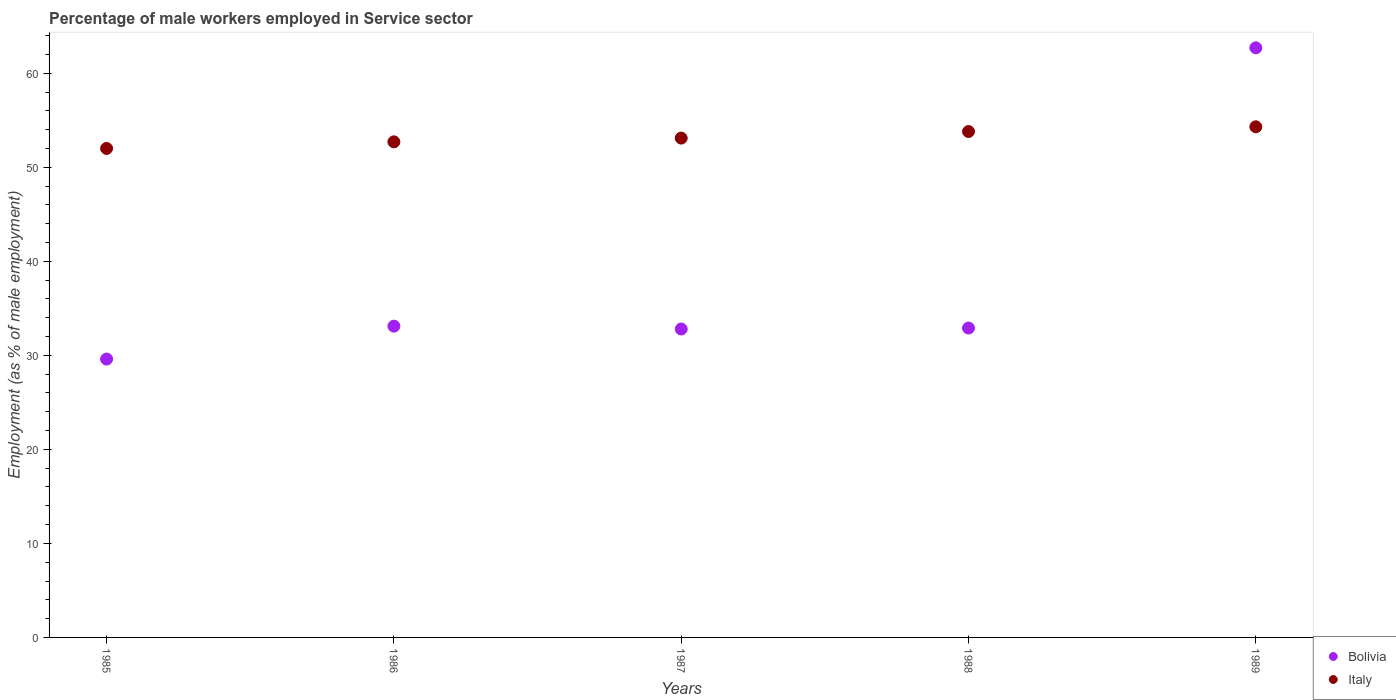How many different coloured dotlines are there?
Provide a succinct answer. 2. What is the percentage of male workers employed in Service sector in Bolivia in 1985?
Ensure brevity in your answer.  29.6. Across all years, what is the maximum percentage of male workers employed in Service sector in Bolivia?
Make the answer very short. 62.7. Across all years, what is the minimum percentage of male workers employed in Service sector in Bolivia?
Keep it short and to the point. 29.6. In which year was the percentage of male workers employed in Service sector in Bolivia maximum?
Keep it short and to the point. 1989. In which year was the percentage of male workers employed in Service sector in Italy minimum?
Give a very brief answer. 1985. What is the total percentage of male workers employed in Service sector in Italy in the graph?
Your response must be concise. 265.9. What is the difference between the percentage of male workers employed in Service sector in Bolivia in 1985 and that in 1988?
Give a very brief answer. -3.3. What is the average percentage of male workers employed in Service sector in Italy per year?
Offer a very short reply. 53.18. In the year 1986, what is the difference between the percentage of male workers employed in Service sector in Bolivia and percentage of male workers employed in Service sector in Italy?
Provide a succinct answer. -19.6. What is the ratio of the percentage of male workers employed in Service sector in Italy in 1987 to that in 1988?
Make the answer very short. 0.99. Is the difference between the percentage of male workers employed in Service sector in Bolivia in 1986 and 1987 greater than the difference between the percentage of male workers employed in Service sector in Italy in 1986 and 1987?
Your answer should be very brief. Yes. What is the difference between the highest and the second highest percentage of male workers employed in Service sector in Italy?
Give a very brief answer. 0.5. What is the difference between the highest and the lowest percentage of male workers employed in Service sector in Italy?
Your answer should be compact. 2.3. Does the percentage of male workers employed in Service sector in Italy monotonically increase over the years?
Keep it short and to the point. Yes. Is the percentage of male workers employed in Service sector in Bolivia strictly greater than the percentage of male workers employed in Service sector in Italy over the years?
Offer a very short reply. No. How many years are there in the graph?
Give a very brief answer. 5. What is the difference between two consecutive major ticks on the Y-axis?
Your answer should be very brief. 10. Does the graph contain any zero values?
Offer a very short reply. No. Does the graph contain grids?
Offer a terse response. No. How many legend labels are there?
Keep it short and to the point. 2. What is the title of the graph?
Provide a succinct answer. Percentage of male workers employed in Service sector. Does "Thailand" appear as one of the legend labels in the graph?
Give a very brief answer. No. What is the label or title of the Y-axis?
Ensure brevity in your answer.  Employment (as % of male employment). What is the Employment (as % of male employment) of Bolivia in 1985?
Give a very brief answer. 29.6. What is the Employment (as % of male employment) of Italy in 1985?
Provide a succinct answer. 52. What is the Employment (as % of male employment) in Bolivia in 1986?
Keep it short and to the point. 33.1. What is the Employment (as % of male employment) of Italy in 1986?
Your response must be concise. 52.7. What is the Employment (as % of male employment) in Bolivia in 1987?
Provide a short and direct response. 32.8. What is the Employment (as % of male employment) of Italy in 1987?
Provide a short and direct response. 53.1. What is the Employment (as % of male employment) in Bolivia in 1988?
Your answer should be compact. 32.9. What is the Employment (as % of male employment) of Italy in 1988?
Your answer should be compact. 53.8. What is the Employment (as % of male employment) in Bolivia in 1989?
Your answer should be compact. 62.7. What is the Employment (as % of male employment) in Italy in 1989?
Your answer should be very brief. 54.3. Across all years, what is the maximum Employment (as % of male employment) in Bolivia?
Your answer should be compact. 62.7. Across all years, what is the maximum Employment (as % of male employment) of Italy?
Your response must be concise. 54.3. Across all years, what is the minimum Employment (as % of male employment) in Bolivia?
Your response must be concise. 29.6. Across all years, what is the minimum Employment (as % of male employment) of Italy?
Your answer should be compact. 52. What is the total Employment (as % of male employment) of Bolivia in the graph?
Provide a short and direct response. 191.1. What is the total Employment (as % of male employment) in Italy in the graph?
Provide a succinct answer. 265.9. What is the difference between the Employment (as % of male employment) of Italy in 1985 and that in 1987?
Keep it short and to the point. -1.1. What is the difference between the Employment (as % of male employment) in Bolivia in 1985 and that in 1988?
Your answer should be compact. -3.3. What is the difference between the Employment (as % of male employment) in Italy in 1985 and that in 1988?
Ensure brevity in your answer.  -1.8. What is the difference between the Employment (as % of male employment) of Bolivia in 1985 and that in 1989?
Provide a short and direct response. -33.1. What is the difference between the Employment (as % of male employment) of Italy in 1986 and that in 1987?
Your answer should be compact. -0.4. What is the difference between the Employment (as % of male employment) in Bolivia in 1986 and that in 1988?
Your response must be concise. 0.2. What is the difference between the Employment (as % of male employment) in Bolivia in 1986 and that in 1989?
Offer a terse response. -29.6. What is the difference between the Employment (as % of male employment) of Bolivia in 1987 and that in 1989?
Offer a very short reply. -29.9. What is the difference between the Employment (as % of male employment) in Bolivia in 1988 and that in 1989?
Ensure brevity in your answer.  -29.8. What is the difference between the Employment (as % of male employment) of Bolivia in 1985 and the Employment (as % of male employment) of Italy in 1986?
Ensure brevity in your answer.  -23.1. What is the difference between the Employment (as % of male employment) of Bolivia in 1985 and the Employment (as % of male employment) of Italy in 1987?
Offer a terse response. -23.5. What is the difference between the Employment (as % of male employment) of Bolivia in 1985 and the Employment (as % of male employment) of Italy in 1988?
Offer a very short reply. -24.2. What is the difference between the Employment (as % of male employment) of Bolivia in 1985 and the Employment (as % of male employment) of Italy in 1989?
Make the answer very short. -24.7. What is the difference between the Employment (as % of male employment) of Bolivia in 1986 and the Employment (as % of male employment) of Italy in 1987?
Provide a short and direct response. -20. What is the difference between the Employment (as % of male employment) in Bolivia in 1986 and the Employment (as % of male employment) in Italy in 1988?
Offer a terse response. -20.7. What is the difference between the Employment (as % of male employment) of Bolivia in 1986 and the Employment (as % of male employment) of Italy in 1989?
Provide a short and direct response. -21.2. What is the difference between the Employment (as % of male employment) in Bolivia in 1987 and the Employment (as % of male employment) in Italy in 1989?
Give a very brief answer. -21.5. What is the difference between the Employment (as % of male employment) of Bolivia in 1988 and the Employment (as % of male employment) of Italy in 1989?
Your answer should be very brief. -21.4. What is the average Employment (as % of male employment) in Bolivia per year?
Offer a very short reply. 38.22. What is the average Employment (as % of male employment) in Italy per year?
Your answer should be very brief. 53.18. In the year 1985, what is the difference between the Employment (as % of male employment) in Bolivia and Employment (as % of male employment) in Italy?
Your response must be concise. -22.4. In the year 1986, what is the difference between the Employment (as % of male employment) of Bolivia and Employment (as % of male employment) of Italy?
Offer a terse response. -19.6. In the year 1987, what is the difference between the Employment (as % of male employment) of Bolivia and Employment (as % of male employment) of Italy?
Give a very brief answer. -20.3. In the year 1988, what is the difference between the Employment (as % of male employment) of Bolivia and Employment (as % of male employment) of Italy?
Keep it short and to the point. -20.9. What is the ratio of the Employment (as % of male employment) of Bolivia in 1985 to that in 1986?
Keep it short and to the point. 0.89. What is the ratio of the Employment (as % of male employment) of Italy in 1985 to that in 1986?
Provide a succinct answer. 0.99. What is the ratio of the Employment (as % of male employment) of Bolivia in 1985 to that in 1987?
Your response must be concise. 0.9. What is the ratio of the Employment (as % of male employment) of Italy in 1985 to that in 1987?
Offer a terse response. 0.98. What is the ratio of the Employment (as % of male employment) in Bolivia in 1985 to that in 1988?
Offer a very short reply. 0.9. What is the ratio of the Employment (as % of male employment) in Italy in 1985 to that in 1988?
Provide a short and direct response. 0.97. What is the ratio of the Employment (as % of male employment) in Bolivia in 1985 to that in 1989?
Make the answer very short. 0.47. What is the ratio of the Employment (as % of male employment) in Italy in 1985 to that in 1989?
Offer a terse response. 0.96. What is the ratio of the Employment (as % of male employment) of Bolivia in 1986 to that in 1987?
Ensure brevity in your answer.  1.01. What is the ratio of the Employment (as % of male employment) of Italy in 1986 to that in 1987?
Offer a terse response. 0.99. What is the ratio of the Employment (as % of male employment) in Italy in 1986 to that in 1988?
Your response must be concise. 0.98. What is the ratio of the Employment (as % of male employment) in Bolivia in 1986 to that in 1989?
Offer a very short reply. 0.53. What is the ratio of the Employment (as % of male employment) of Italy in 1986 to that in 1989?
Ensure brevity in your answer.  0.97. What is the ratio of the Employment (as % of male employment) in Italy in 1987 to that in 1988?
Ensure brevity in your answer.  0.99. What is the ratio of the Employment (as % of male employment) in Bolivia in 1987 to that in 1989?
Provide a succinct answer. 0.52. What is the ratio of the Employment (as % of male employment) in Italy in 1987 to that in 1989?
Ensure brevity in your answer.  0.98. What is the ratio of the Employment (as % of male employment) of Bolivia in 1988 to that in 1989?
Your answer should be very brief. 0.52. What is the difference between the highest and the second highest Employment (as % of male employment) of Bolivia?
Keep it short and to the point. 29.6. What is the difference between the highest and the second highest Employment (as % of male employment) in Italy?
Your response must be concise. 0.5. What is the difference between the highest and the lowest Employment (as % of male employment) in Bolivia?
Make the answer very short. 33.1. 